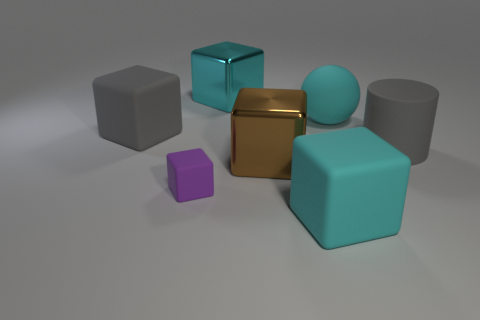Subtract all small matte blocks. How many blocks are left? 4 Subtract all blue spheres. How many cyan blocks are left? 2 Subtract all cyan blocks. How many blocks are left? 3 Subtract 2 cubes. How many cubes are left? 3 Add 1 matte cylinders. How many objects exist? 8 Subtract all red blocks. Subtract all blue cylinders. How many blocks are left? 5 Subtract all cylinders. How many objects are left? 6 Add 2 big gray cylinders. How many big gray cylinders are left? 3 Add 1 big rubber things. How many big rubber things exist? 5 Subtract 0 purple cylinders. How many objects are left? 7 